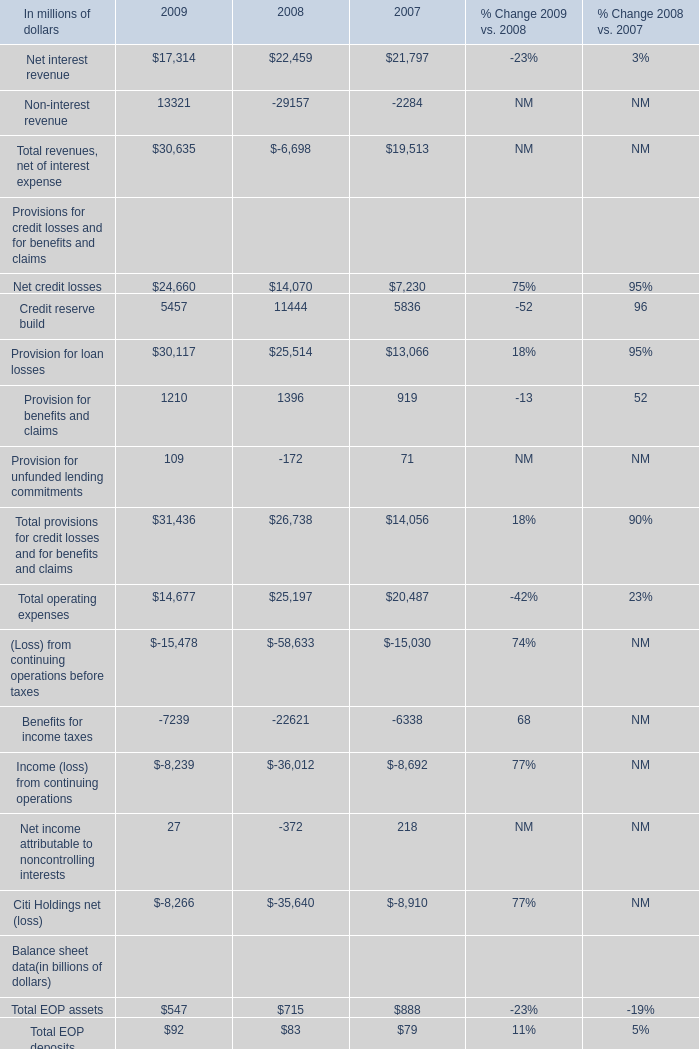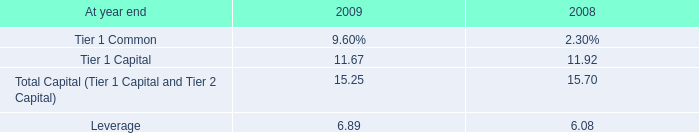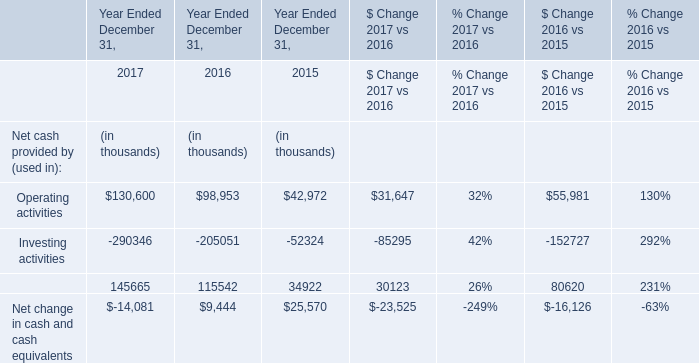Which year has the greatest proportion of Net interest revenue? 
Answer: 2008. 